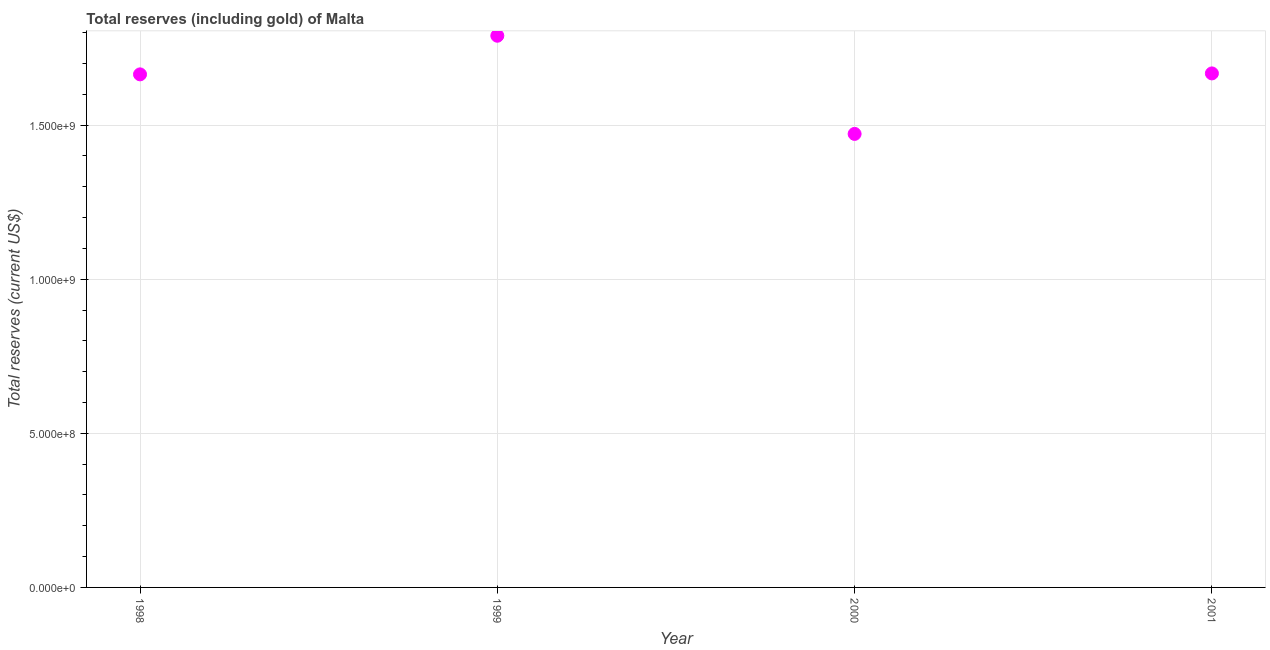What is the total reserves (including gold) in 1999?
Keep it short and to the point. 1.79e+09. Across all years, what is the maximum total reserves (including gold)?
Offer a very short reply. 1.79e+09. Across all years, what is the minimum total reserves (including gold)?
Your response must be concise. 1.47e+09. In which year was the total reserves (including gold) minimum?
Keep it short and to the point. 2000. What is the sum of the total reserves (including gold)?
Your answer should be compact. 6.59e+09. What is the difference between the total reserves (including gold) in 1998 and 2000?
Your answer should be very brief. 1.93e+08. What is the average total reserves (including gold) per year?
Your answer should be very brief. 1.65e+09. What is the median total reserves (including gold)?
Your response must be concise. 1.67e+09. What is the ratio of the total reserves (including gold) in 1998 to that in 1999?
Your answer should be very brief. 0.93. Is the total reserves (including gold) in 1998 less than that in 2000?
Your answer should be very brief. No. Is the difference between the total reserves (including gold) in 1998 and 2000 greater than the difference between any two years?
Provide a succinct answer. No. What is the difference between the highest and the second highest total reserves (including gold)?
Make the answer very short. 1.22e+08. What is the difference between the highest and the lowest total reserves (including gold)?
Your answer should be very brief. 3.18e+08. Does the total reserves (including gold) monotonically increase over the years?
Your answer should be very brief. No. Does the graph contain any zero values?
Make the answer very short. No. Does the graph contain grids?
Offer a terse response. Yes. What is the title of the graph?
Offer a terse response. Total reserves (including gold) of Malta. What is the label or title of the Y-axis?
Provide a succinct answer. Total reserves (current US$). What is the Total reserves (current US$) in 1998?
Make the answer very short. 1.66e+09. What is the Total reserves (current US$) in 1999?
Your answer should be compact. 1.79e+09. What is the Total reserves (current US$) in 2000?
Your answer should be compact. 1.47e+09. What is the Total reserves (current US$) in 2001?
Provide a succinct answer. 1.67e+09. What is the difference between the Total reserves (current US$) in 1998 and 1999?
Provide a succinct answer. -1.25e+08. What is the difference between the Total reserves (current US$) in 1998 and 2000?
Keep it short and to the point. 1.93e+08. What is the difference between the Total reserves (current US$) in 1998 and 2001?
Provide a succinct answer. -3.11e+06. What is the difference between the Total reserves (current US$) in 1999 and 2000?
Provide a succinct answer. 3.18e+08. What is the difference between the Total reserves (current US$) in 1999 and 2001?
Give a very brief answer. 1.22e+08. What is the difference between the Total reserves (current US$) in 2000 and 2001?
Offer a terse response. -1.96e+08. What is the ratio of the Total reserves (current US$) in 1998 to that in 2000?
Offer a terse response. 1.13. What is the ratio of the Total reserves (current US$) in 1998 to that in 2001?
Give a very brief answer. 1. What is the ratio of the Total reserves (current US$) in 1999 to that in 2000?
Ensure brevity in your answer.  1.22. What is the ratio of the Total reserves (current US$) in 1999 to that in 2001?
Provide a short and direct response. 1.07. What is the ratio of the Total reserves (current US$) in 2000 to that in 2001?
Provide a short and direct response. 0.88. 